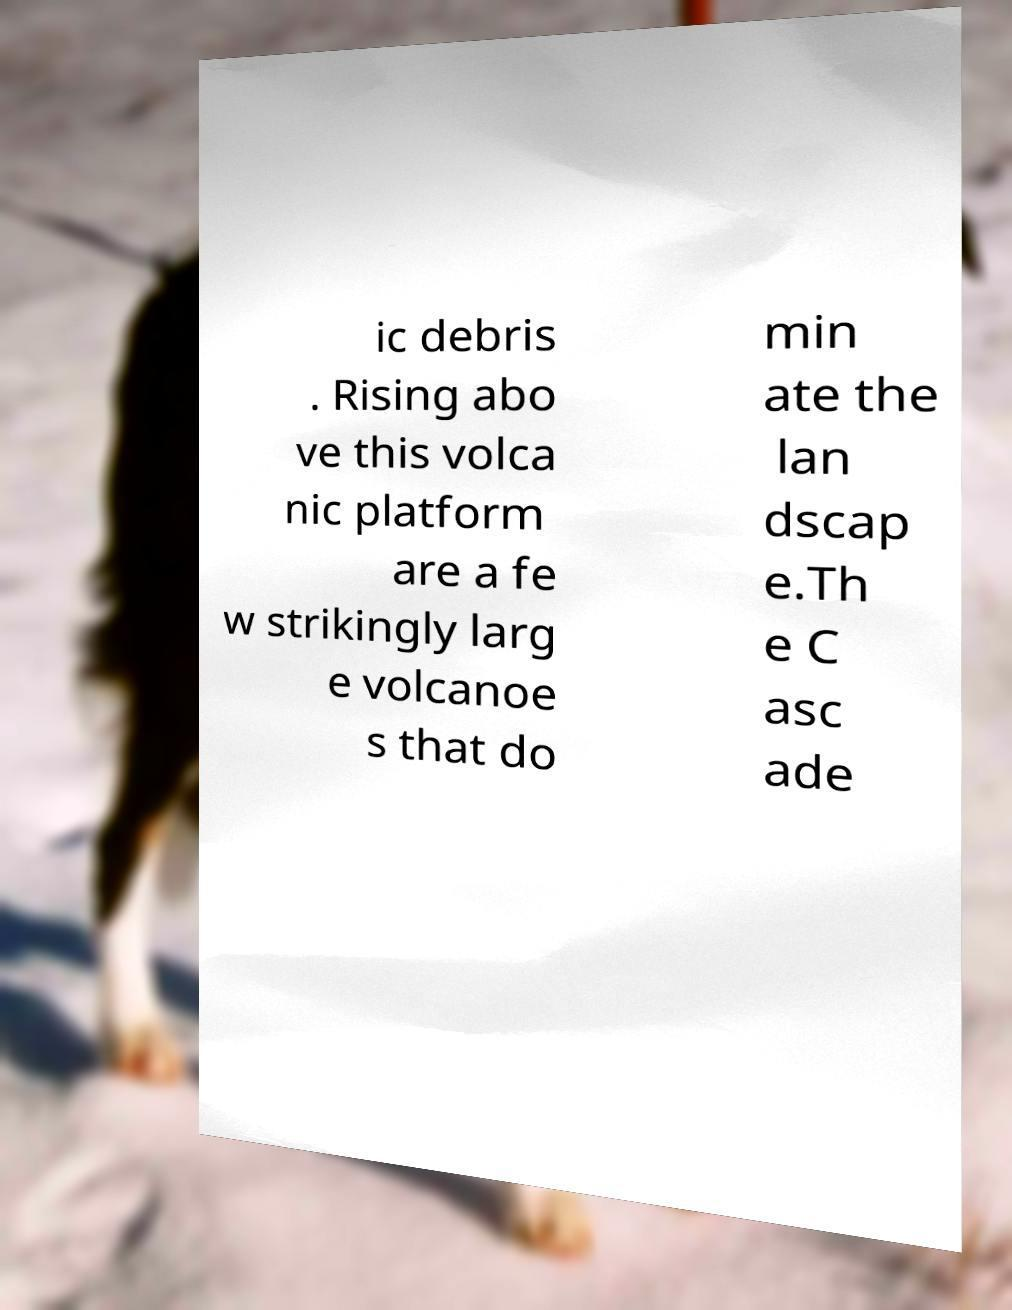Please read and relay the text visible in this image. What does it say? ic debris . Rising abo ve this volca nic platform are a fe w strikingly larg e volcanoe s that do min ate the lan dscap e.Th e C asc ade 